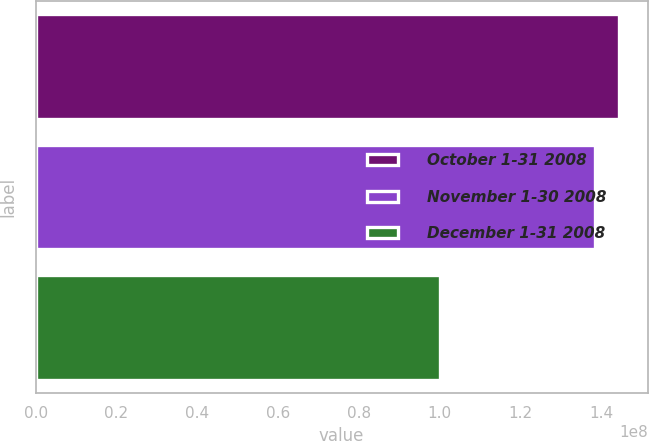<chart> <loc_0><loc_0><loc_500><loc_500><bar_chart><fcel>October 1-31 2008<fcel>November 1-30 2008<fcel>December 1-31 2008<nl><fcel>1.44249e+08<fcel>1.38362e+08<fcel>1e+08<nl></chart> 